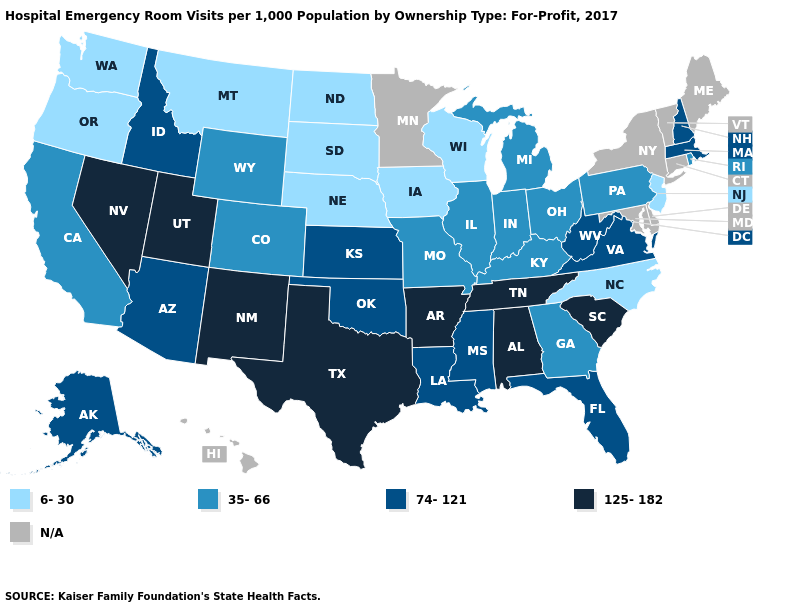Among the states that border California , does Nevada have the highest value?
Concise answer only. Yes. What is the value of Hawaii?
Answer briefly. N/A. What is the value of Florida?
Quick response, please. 74-121. Which states have the lowest value in the USA?
Quick response, please. Iowa, Montana, Nebraska, New Jersey, North Carolina, North Dakota, Oregon, South Dakota, Washington, Wisconsin. What is the value of Wyoming?
Be succinct. 35-66. Among the states that border Alabama , which have the lowest value?
Concise answer only. Georgia. Is the legend a continuous bar?
Short answer required. No. What is the value of Arizona?
Answer briefly. 74-121. Name the states that have a value in the range 6-30?
Answer briefly. Iowa, Montana, Nebraska, New Jersey, North Carolina, North Dakota, Oregon, South Dakota, Washington, Wisconsin. Is the legend a continuous bar?
Be succinct. No. What is the value of Vermont?
Quick response, please. N/A. Does Arkansas have the highest value in the South?
Write a very short answer. Yes. Which states hav the highest value in the West?
Write a very short answer. Nevada, New Mexico, Utah. What is the value of Tennessee?
Short answer required. 125-182. Does Washington have the lowest value in the West?
Write a very short answer. Yes. 